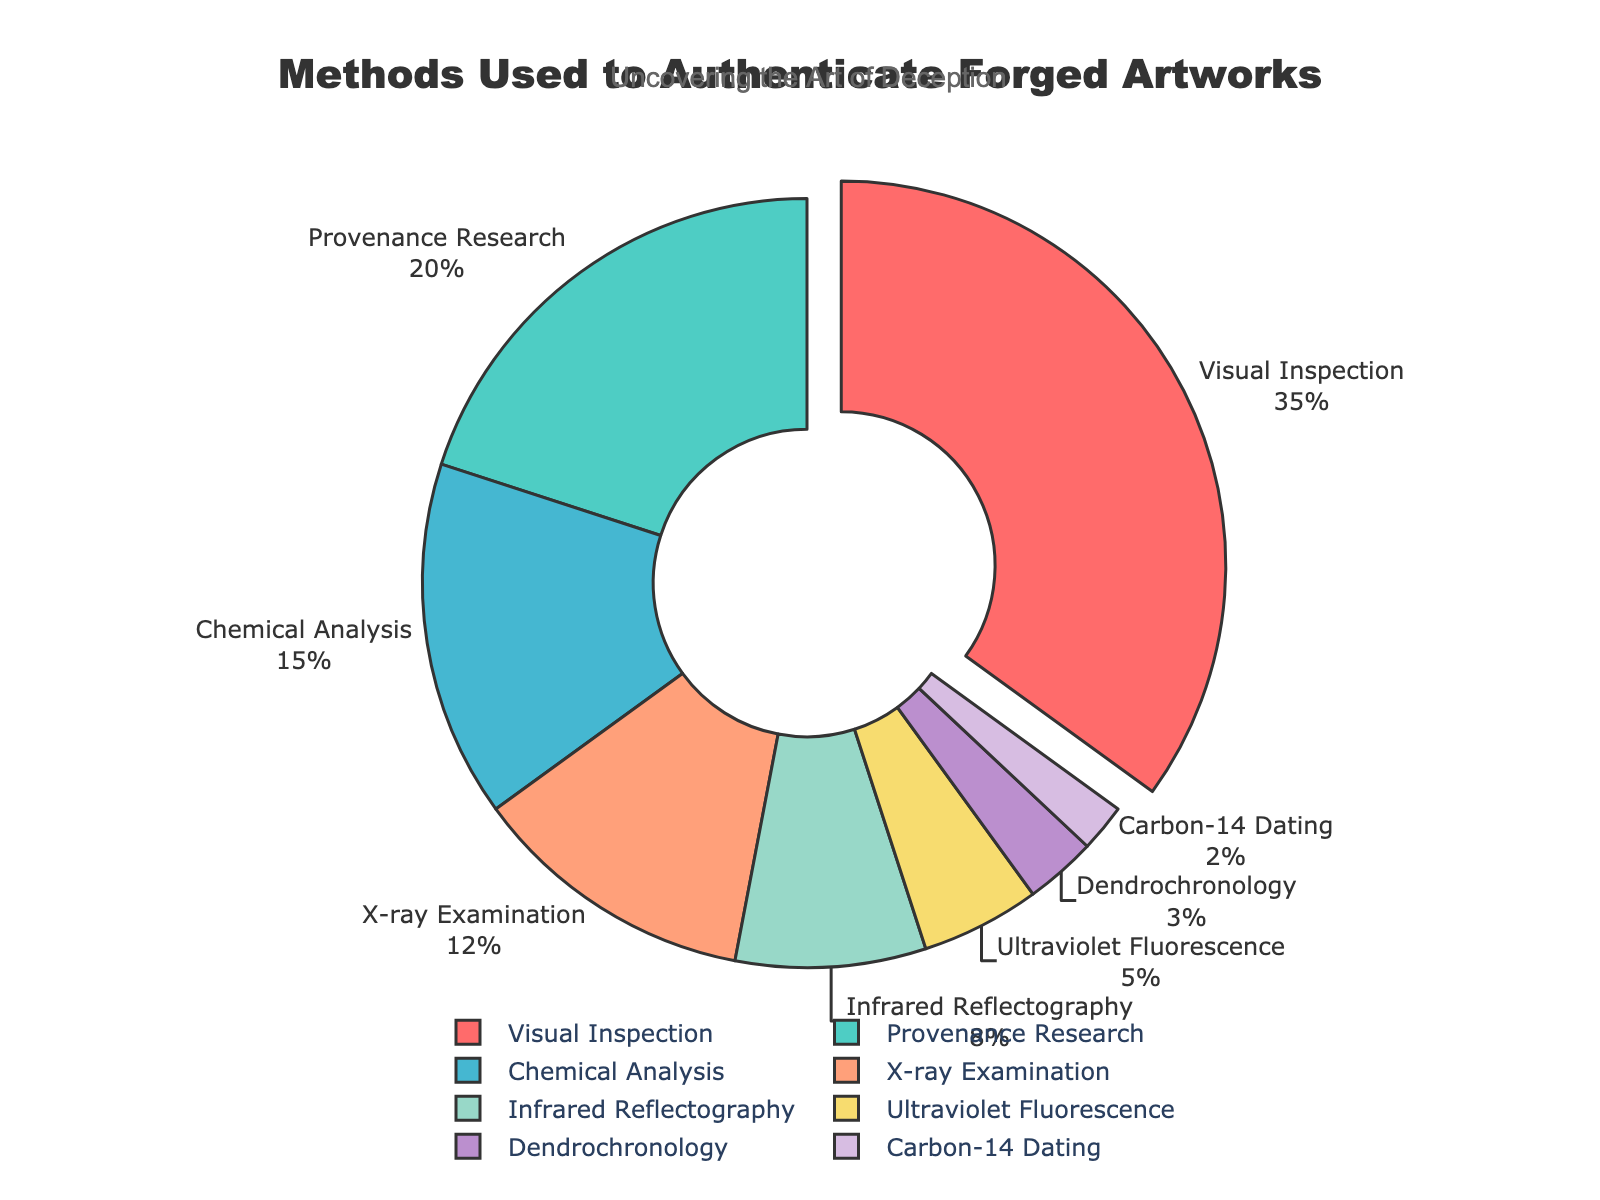what method is used most often to authenticate forged artworks? The figure highlights that "Visual Inspection" is used most frequently to authenticate forged artworks, evidenced by its largest segment in the pie chart.
Answer: Visual Inspection what percentage of authentication methods use Infrared Reflectography? The figure shows that Infrared Reflectography accounts for 8% of the methods used to authenticate forged artworks, as indicated by the respective segment of the pie chart.
Answer: 8% How much higher is the percentage use of Chemical Analysis compared to Dendrochronology? The percentage for Chemical Analysis is 15%, while Dendrochronology is 3%. The difference is calculated by subtracting the smaller percentage from the larger one: 15% - 3% = 12%.
Answer: 12% Combine the percentages of provenance research, ultraviolet fluorescence, and carbon-14 dating. What’s the total? Adding the percentages for Provenance Research (20%), Ultraviolet Fluorescence (5%), and Carbon-14 Dating (2%) gives: 20% + 5% + 2% = 27%.
Answer: 27% Which method has a higher percentage, Provenance Research or X-ray Examination? The pie chart indicates that Provenance Research has 20% and X-ray Examination has 12%. Therefore, Provenance Research has a higher percentage.
Answer: Provenance Research What method's percentage is half that of Visual Inspection? Visual Inspection has a percentage of 35%. Half of this is calculated as 35% / 2 = 17.5%. The closest lower value in the figure is Provenance Research at 20%, which is not exactly half but closest to half. Therefore, no method perfectly matches half, but Provenance Research is close.
Answer: None perfectly match but Provenance Research is close Which methods collectively make up over half of the authentication techniques used? Visual Inspection (35%) and Provenance Research (20%) collectively sum to: 35% + 20% = 55%, which is more than half.
Answer: Visual Inspection and Provenance Research What is the least used method? The smallest segment in the pie chart represents Carbon-14 Dating, with a 2% usage.
Answer: Carbon-14 Dating 